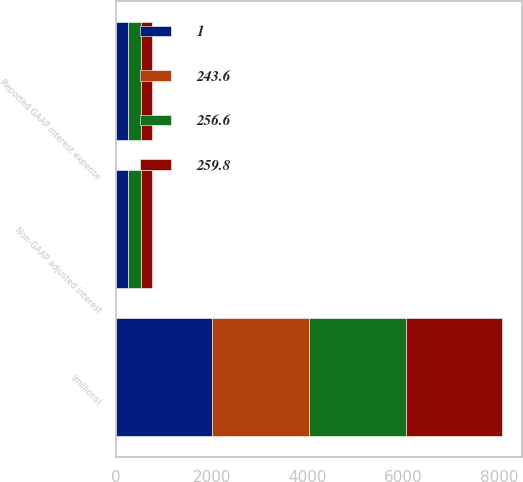<chart> <loc_0><loc_0><loc_500><loc_500><stacked_bar_chart><ecel><fcel>(millions)<fcel>Reported GAAP interest expense<fcel>Non-GAAP adjusted interest<nl><fcel>259.8<fcel>2015<fcel>243.6<fcel>243.6<nl><fcel>256.6<fcel>2014<fcel>256.6<fcel>256.6<nl><fcel>1<fcel>2013<fcel>262.3<fcel>259.8<nl><fcel>243.6<fcel>2015<fcel>5<fcel>5<nl></chart> 